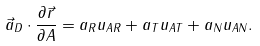<formula> <loc_0><loc_0><loc_500><loc_500>\vec { a } _ { D } \cdot \frac { \partial \vec { r } } { \partial A } = a _ { R } u _ { A R } + a _ { T } u _ { A T } + a _ { N } u _ { A N } .</formula> 